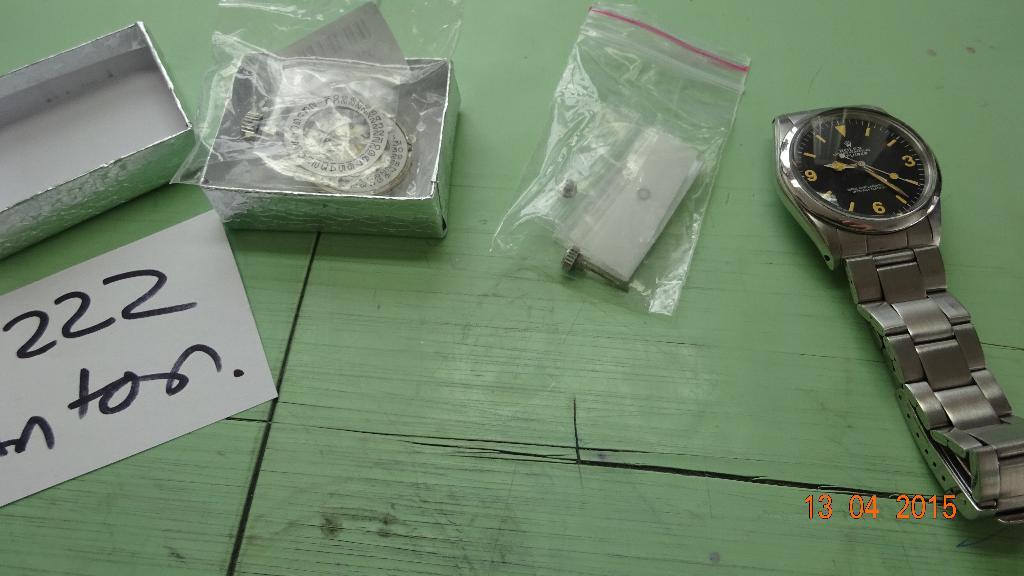What are the numbers to the left?
Make the answer very short. 222. What time does the watch read?
Offer a very short reply. 9:24. 